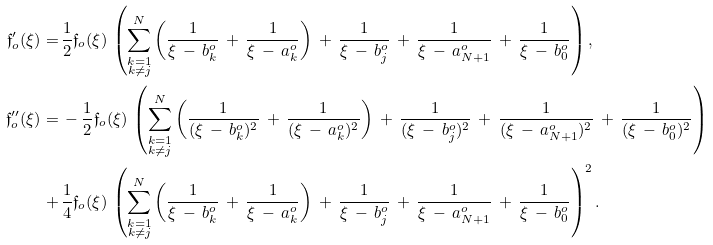Convert formula to latex. <formula><loc_0><loc_0><loc_500><loc_500>\mathfrak { f } _ { o } ^ { \prime } ( \xi ) = & \, \frac { 1 } { 2 } \mathfrak { f } _ { o } ( \xi ) \, \left ( \sum _ { \substack { k = 1 \\ k \not = j } } ^ { N } \left ( \frac { 1 } { \xi \, - \, b _ { k } ^ { o } } \, + \, \frac { 1 } { \xi \, - \, a _ { k } ^ { o } } \right ) \, + \, \frac { 1 } { \xi \, - \, b _ { j } ^ { o } } \, + \, \frac { 1 } { \xi \, - \, a _ { N + 1 } ^ { o } } \, + \, \frac { 1 } { \xi \, - \, b _ { 0 } ^ { o } } \right ) , \\ \mathfrak { f } _ { o } ^ { \prime \prime } ( \xi ) = & \, - \frac { 1 } { 2 } \mathfrak { f } _ { o } ( \xi ) \, \left ( \sum _ { \substack { k = 1 \\ k \not = j } } ^ { N } \left ( \frac { 1 } { ( \xi \, - \, b _ { k } ^ { o } ) ^ { 2 } } \, + \, \frac { 1 } { ( \xi \, - \, a _ { k } ^ { o } ) ^ { 2 } } \right ) \, + \, \frac { 1 } { ( \xi \, - \, b _ { j } ^ { o } ) ^ { 2 } } \, + \, \frac { 1 } { ( \xi \, - \, a _ { N + 1 } ^ { o } ) ^ { 2 } } \, + \, \frac { 1 } { ( \xi \, - \, b _ { 0 } ^ { o } ) ^ { 2 } } \right ) \\ + & \, \frac { 1 } { 4 } \mathfrak { f } _ { o } ( \xi ) \, \left ( \sum _ { \substack { k = 1 \\ k \not = j } } ^ { N } \left ( \frac { 1 } { \xi \, - \, b _ { k } ^ { o } } \, + \, \frac { 1 } { \xi \, - \, a _ { k } ^ { o } } \right ) \, + \, \frac { 1 } { \xi \, - \, b _ { j } ^ { o } } \, + \, \frac { 1 } { \xi \, - \, a _ { N + 1 } ^ { o } } \, + \, \frac { 1 } { \xi \, - \, b _ { 0 } ^ { o } } \right ) ^ { 2 } .</formula> 